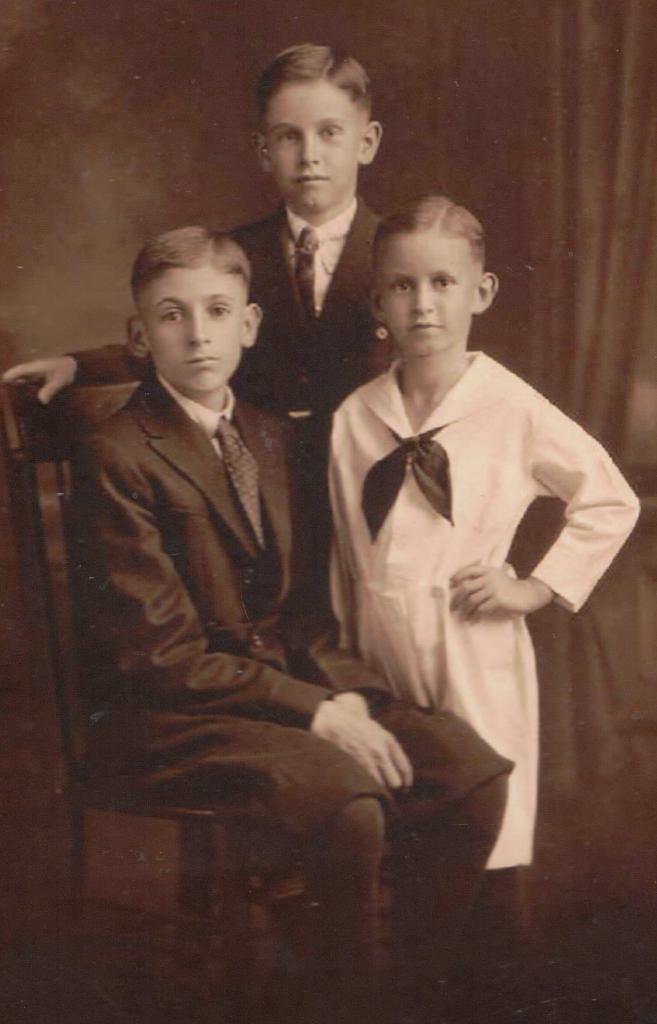Please provide a concise description of this image. In this image, we can see three people. Here a boy is sitting on a chair. Background we can see a wall and curtain. 